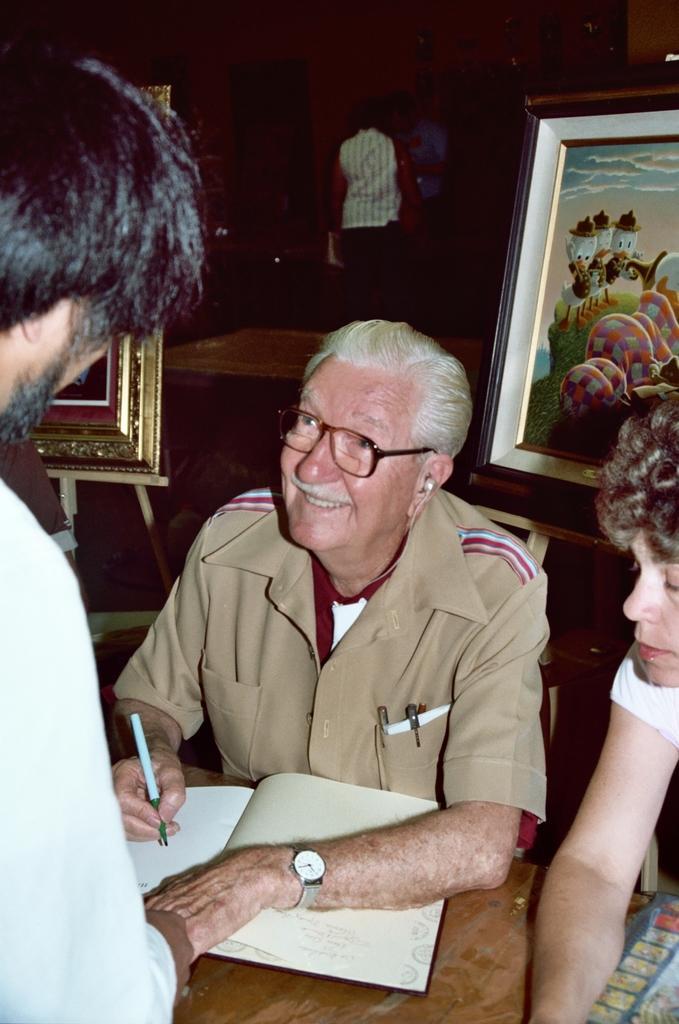In one or two sentences, can you explain what this image depicts? This image consists of three persons. In the middle, we can see a book and a pen. In the background, there are photo frames. And we can see a person standing. 